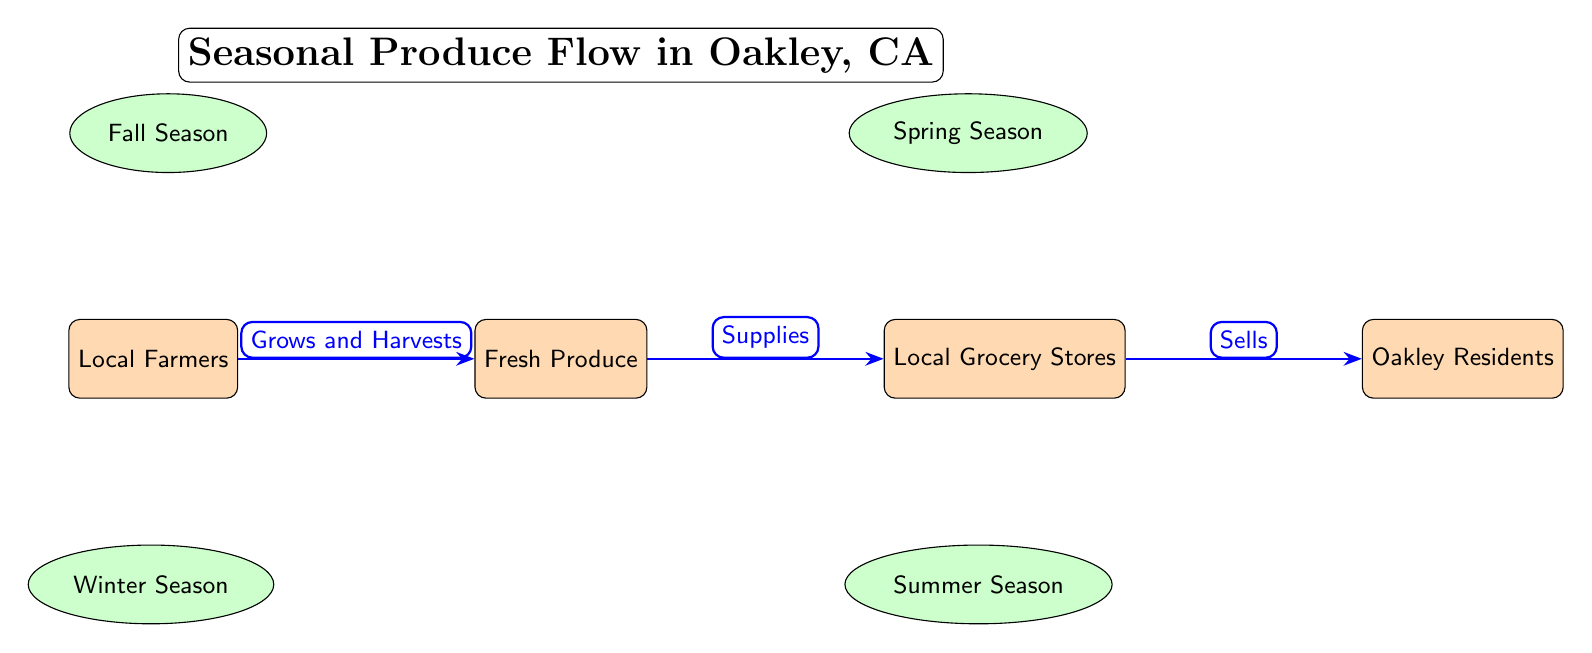What's the first actor in the food chain? The first actor is the one positioned on the far left of the diagram, which is "Local Farmers".
Answer: Local Farmers What type of produce is supplied in the winter? The winter season is linked to "Citrus, Kale", which indicates these are the types of produce supplied during that season.
Answer: Citrus, Kale How many seasons are mentioned in the diagram? There are four labeled seasons in the diagram: Fall, Spring, Winter, and Summer, making a total of four seasons.
Answer: 4 Who buys the produce from local grocery stores? The buyers are labeled as "Oakley Residents", which indicates who purchases the products sold by the grocery stores.
Answer: Oakley Residents What is the supply relationship between fresh produce and local grocery stores? The diagram shows that fresh produce is supplied to local grocery stores, represented by the arrow labeled "Supplies" pointing from produce to stores.
Answer: Supplies What fruits and vegetables are available in the summer? The summer season is linked to "Tomatoes, Peaches", indicating these are the types of produce available during that season.
Answer: Tomatoes, Peaches Which season offers apples and pumpkins? According to the diagram, both apples and pumpkins are available during the fall season, as indicated by the arrow pointing from fall to produce.
Answer: Fall Season What happens after local farmers grow and harvest produce? After the local farmers grow and harvest, they supply the fresh produce to local grocery stores, which is indicated by the flow of the arrows in the diagram.
Answer: Supplies How does the seasonal availability of produce impact local grocery stores? The seasonal availability of produce influences what types of fresh produce can be supplied to local grocery stores, thus affecting their inventory based on the seasons indicated in the diagram.
Answer: Affects inventory 